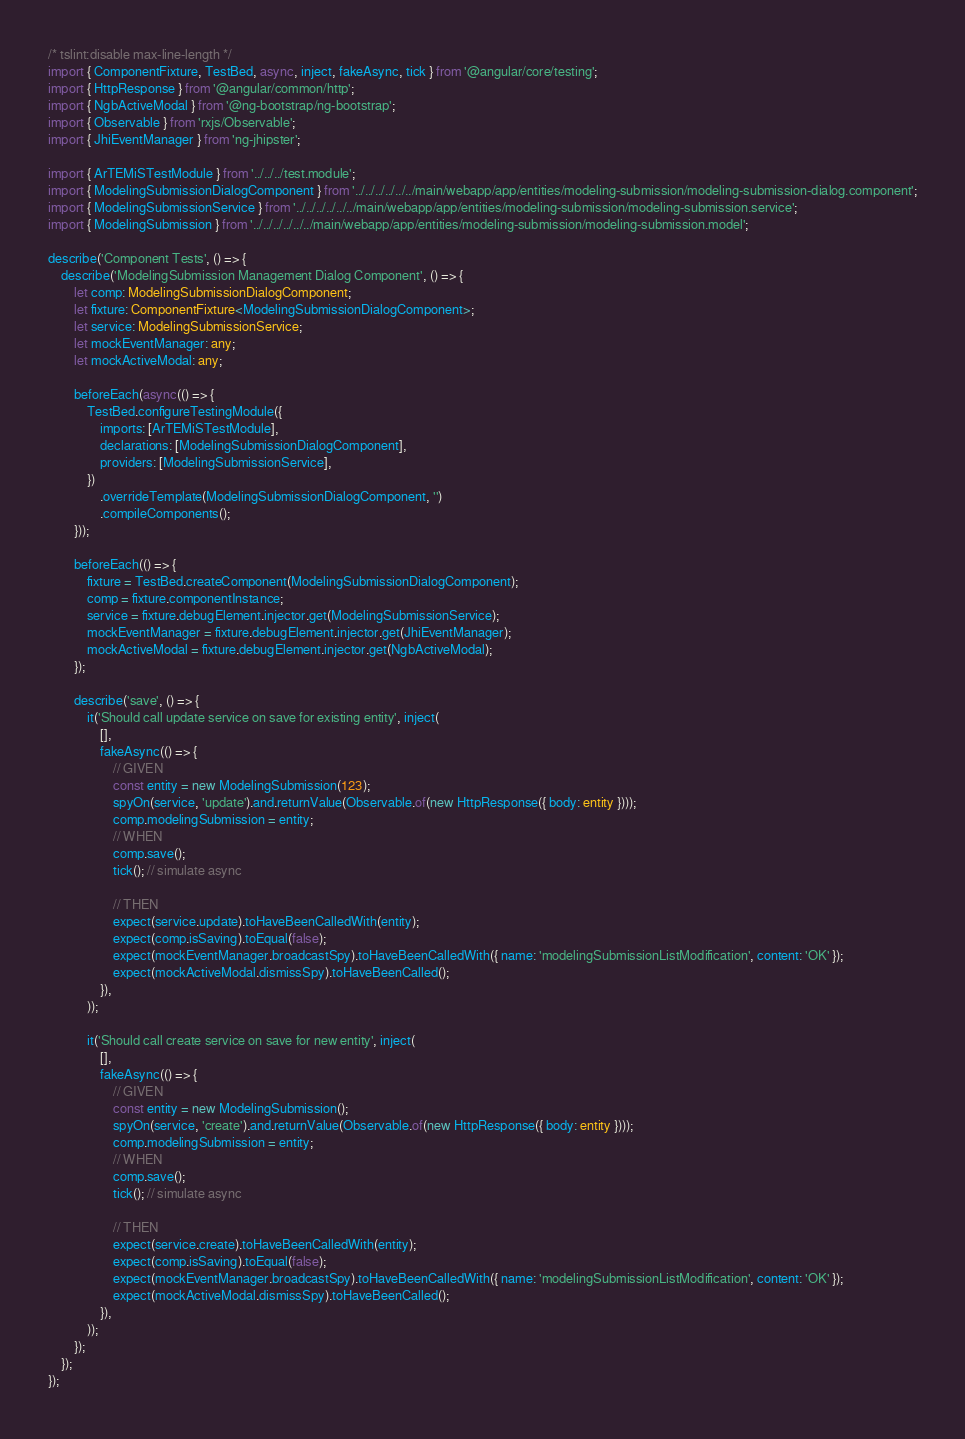Convert code to text. <code><loc_0><loc_0><loc_500><loc_500><_TypeScript_>/* tslint:disable max-line-length */
import { ComponentFixture, TestBed, async, inject, fakeAsync, tick } from '@angular/core/testing';
import { HttpResponse } from '@angular/common/http';
import { NgbActiveModal } from '@ng-bootstrap/ng-bootstrap';
import { Observable } from 'rxjs/Observable';
import { JhiEventManager } from 'ng-jhipster';

import { ArTEMiSTestModule } from '../../../test.module';
import { ModelingSubmissionDialogComponent } from '../../../../../../main/webapp/app/entities/modeling-submission/modeling-submission-dialog.component';
import { ModelingSubmissionService } from '../../../../../../main/webapp/app/entities/modeling-submission/modeling-submission.service';
import { ModelingSubmission } from '../../../../../../main/webapp/app/entities/modeling-submission/modeling-submission.model';

describe('Component Tests', () => {
    describe('ModelingSubmission Management Dialog Component', () => {
        let comp: ModelingSubmissionDialogComponent;
        let fixture: ComponentFixture<ModelingSubmissionDialogComponent>;
        let service: ModelingSubmissionService;
        let mockEventManager: any;
        let mockActiveModal: any;

        beforeEach(async(() => {
            TestBed.configureTestingModule({
                imports: [ArTEMiSTestModule],
                declarations: [ModelingSubmissionDialogComponent],
                providers: [ModelingSubmissionService],
            })
                .overrideTemplate(ModelingSubmissionDialogComponent, '')
                .compileComponents();
        }));

        beforeEach(() => {
            fixture = TestBed.createComponent(ModelingSubmissionDialogComponent);
            comp = fixture.componentInstance;
            service = fixture.debugElement.injector.get(ModelingSubmissionService);
            mockEventManager = fixture.debugElement.injector.get(JhiEventManager);
            mockActiveModal = fixture.debugElement.injector.get(NgbActiveModal);
        });

        describe('save', () => {
            it('Should call update service on save for existing entity', inject(
                [],
                fakeAsync(() => {
                    // GIVEN
                    const entity = new ModelingSubmission(123);
                    spyOn(service, 'update').and.returnValue(Observable.of(new HttpResponse({ body: entity })));
                    comp.modelingSubmission = entity;
                    // WHEN
                    comp.save();
                    tick(); // simulate async

                    // THEN
                    expect(service.update).toHaveBeenCalledWith(entity);
                    expect(comp.isSaving).toEqual(false);
                    expect(mockEventManager.broadcastSpy).toHaveBeenCalledWith({ name: 'modelingSubmissionListModification', content: 'OK' });
                    expect(mockActiveModal.dismissSpy).toHaveBeenCalled();
                }),
            ));

            it('Should call create service on save for new entity', inject(
                [],
                fakeAsync(() => {
                    // GIVEN
                    const entity = new ModelingSubmission();
                    spyOn(service, 'create').and.returnValue(Observable.of(new HttpResponse({ body: entity })));
                    comp.modelingSubmission = entity;
                    // WHEN
                    comp.save();
                    tick(); // simulate async

                    // THEN
                    expect(service.create).toHaveBeenCalledWith(entity);
                    expect(comp.isSaving).toEqual(false);
                    expect(mockEventManager.broadcastSpy).toHaveBeenCalledWith({ name: 'modelingSubmissionListModification', content: 'OK' });
                    expect(mockActiveModal.dismissSpy).toHaveBeenCalled();
                }),
            ));
        });
    });
});
</code> 